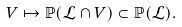Convert formula to latex. <formula><loc_0><loc_0><loc_500><loc_500>V \mapsto \mathbb { P } ( \mathcal { L } \cap V ) \subset \mathbb { P } ( \mathcal { L } ) .</formula> 